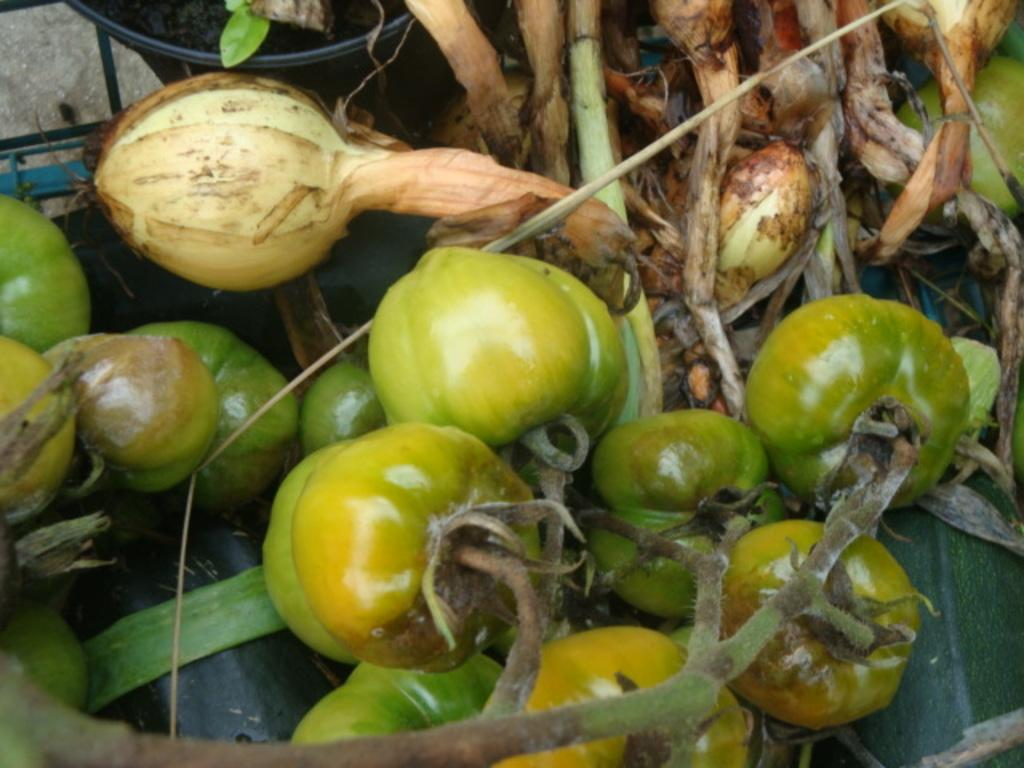What type of food is present in the image? There are tomatoes in the image. What other types of food can be seen in the image? There are other vegetables in the image. What role does the actor play in the image? There is no actor present in the image; it features tomatoes and other vegetables. What type of watch can be seen on the vegetables in the image? There is no watch present in the image; it features tomatoes and other vegetables. 